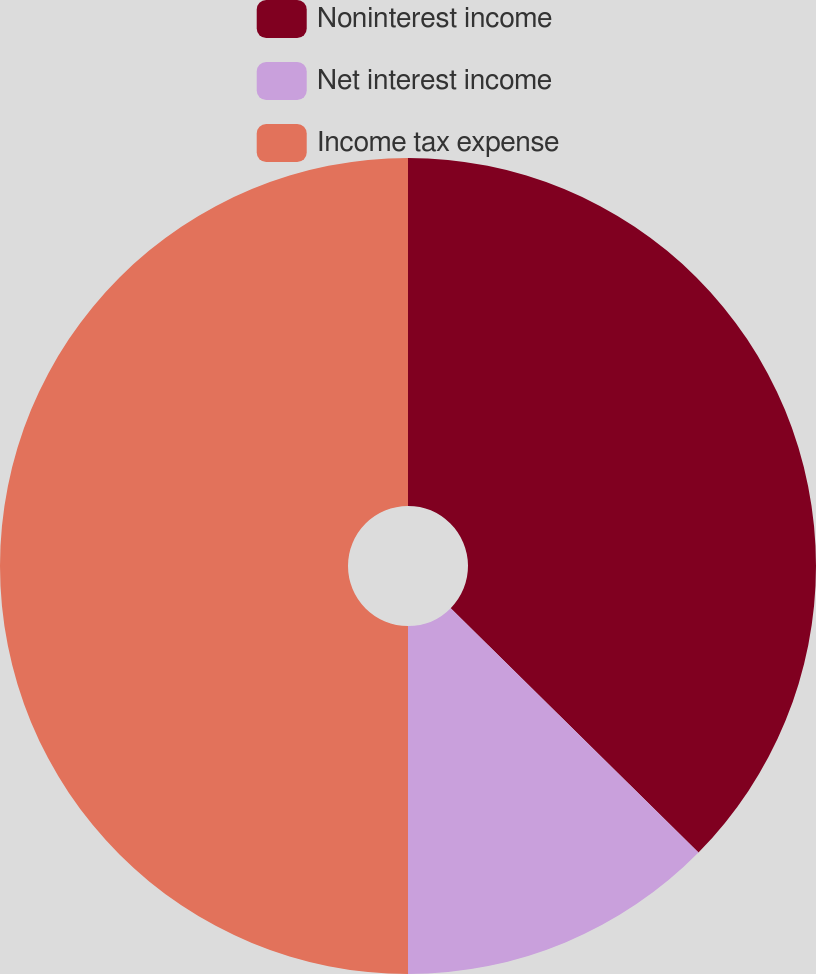Convert chart. <chart><loc_0><loc_0><loc_500><loc_500><pie_chart><fcel>Noninterest income<fcel>Net interest income<fcel>Income tax expense<nl><fcel>37.39%<fcel>12.61%<fcel>50.0%<nl></chart> 